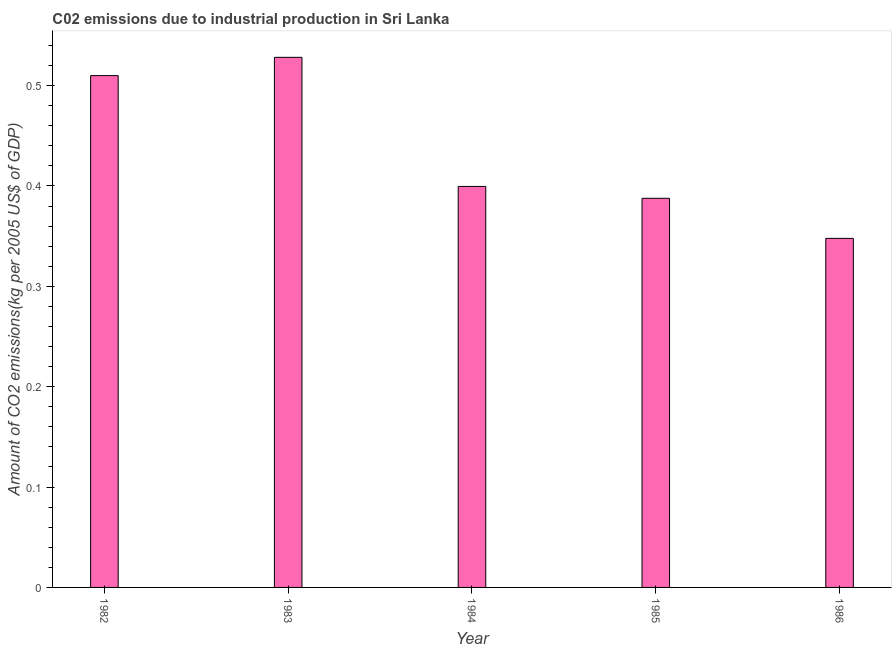Does the graph contain any zero values?
Keep it short and to the point. No. Does the graph contain grids?
Your response must be concise. No. What is the title of the graph?
Make the answer very short. C02 emissions due to industrial production in Sri Lanka. What is the label or title of the X-axis?
Keep it short and to the point. Year. What is the label or title of the Y-axis?
Provide a succinct answer. Amount of CO2 emissions(kg per 2005 US$ of GDP). What is the amount of co2 emissions in 1983?
Provide a succinct answer. 0.53. Across all years, what is the maximum amount of co2 emissions?
Ensure brevity in your answer.  0.53. Across all years, what is the minimum amount of co2 emissions?
Provide a short and direct response. 0.35. In which year was the amount of co2 emissions minimum?
Give a very brief answer. 1986. What is the sum of the amount of co2 emissions?
Your answer should be compact. 2.17. What is the difference between the amount of co2 emissions in 1982 and 1986?
Ensure brevity in your answer.  0.16. What is the average amount of co2 emissions per year?
Offer a very short reply. 0.43. What is the median amount of co2 emissions?
Make the answer very short. 0.4. In how many years, is the amount of co2 emissions greater than 0.34 kg per 2005 US$ of GDP?
Offer a very short reply. 5. Do a majority of the years between 1986 and 1983 (inclusive) have amount of co2 emissions greater than 0.04 kg per 2005 US$ of GDP?
Give a very brief answer. Yes. What is the ratio of the amount of co2 emissions in 1982 to that in 1983?
Provide a succinct answer. 0.97. Is the amount of co2 emissions in 1982 less than that in 1986?
Provide a short and direct response. No. What is the difference between the highest and the second highest amount of co2 emissions?
Your response must be concise. 0.02. Is the sum of the amount of co2 emissions in 1982 and 1983 greater than the maximum amount of co2 emissions across all years?
Keep it short and to the point. Yes. What is the difference between the highest and the lowest amount of co2 emissions?
Your response must be concise. 0.18. How many bars are there?
Keep it short and to the point. 5. Are all the bars in the graph horizontal?
Give a very brief answer. No. How many years are there in the graph?
Provide a short and direct response. 5. Are the values on the major ticks of Y-axis written in scientific E-notation?
Offer a very short reply. No. What is the Amount of CO2 emissions(kg per 2005 US$ of GDP) in 1982?
Make the answer very short. 0.51. What is the Amount of CO2 emissions(kg per 2005 US$ of GDP) of 1983?
Provide a succinct answer. 0.53. What is the Amount of CO2 emissions(kg per 2005 US$ of GDP) of 1984?
Offer a terse response. 0.4. What is the Amount of CO2 emissions(kg per 2005 US$ of GDP) of 1985?
Ensure brevity in your answer.  0.39. What is the Amount of CO2 emissions(kg per 2005 US$ of GDP) in 1986?
Your answer should be compact. 0.35. What is the difference between the Amount of CO2 emissions(kg per 2005 US$ of GDP) in 1982 and 1983?
Provide a succinct answer. -0.02. What is the difference between the Amount of CO2 emissions(kg per 2005 US$ of GDP) in 1982 and 1984?
Keep it short and to the point. 0.11. What is the difference between the Amount of CO2 emissions(kg per 2005 US$ of GDP) in 1982 and 1985?
Keep it short and to the point. 0.12. What is the difference between the Amount of CO2 emissions(kg per 2005 US$ of GDP) in 1982 and 1986?
Provide a short and direct response. 0.16. What is the difference between the Amount of CO2 emissions(kg per 2005 US$ of GDP) in 1983 and 1984?
Offer a terse response. 0.13. What is the difference between the Amount of CO2 emissions(kg per 2005 US$ of GDP) in 1983 and 1985?
Provide a short and direct response. 0.14. What is the difference between the Amount of CO2 emissions(kg per 2005 US$ of GDP) in 1983 and 1986?
Provide a short and direct response. 0.18. What is the difference between the Amount of CO2 emissions(kg per 2005 US$ of GDP) in 1984 and 1985?
Keep it short and to the point. 0.01. What is the difference between the Amount of CO2 emissions(kg per 2005 US$ of GDP) in 1984 and 1986?
Your answer should be compact. 0.05. What is the difference between the Amount of CO2 emissions(kg per 2005 US$ of GDP) in 1985 and 1986?
Ensure brevity in your answer.  0.04. What is the ratio of the Amount of CO2 emissions(kg per 2005 US$ of GDP) in 1982 to that in 1984?
Give a very brief answer. 1.28. What is the ratio of the Amount of CO2 emissions(kg per 2005 US$ of GDP) in 1982 to that in 1985?
Your answer should be very brief. 1.31. What is the ratio of the Amount of CO2 emissions(kg per 2005 US$ of GDP) in 1982 to that in 1986?
Give a very brief answer. 1.47. What is the ratio of the Amount of CO2 emissions(kg per 2005 US$ of GDP) in 1983 to that in 1984?
Your response must be concise. 1.32. What is the ratio of the Amount of CO2 emissions(kg per 2005 US$ of GDP) in 1983 to that in 1985?
Keep it short and to the point. 1.36. What is the ratio of the Amount of CO2 emissions(kg per 2005 US$ of GDP) in 1983 to that in 1986?
Offer a terse response. 1.52. What is the ratio of the Amount of CO2 emissions(kg per 2005 US$ of GDP) in 1984 to that in 1985?
Your answer should be very brief. 1.03. What is the ratio of the Amount of CO2 emissions(kg per 2005 US$ of GDP) in 1984 to that in 1986?
Your response must be concise. 1.15. What is the ratio of the Amount of CO2 emissions(kg per 2005 US$ of GDP) in 1985 to that in 1986?
Keep it short and to the point. 1.11. 